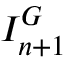Convert formula to latex. <formula><loc_0><loc_0><loc_500><loc_500>I _ { n + 1 } ^ { G }</formula> 